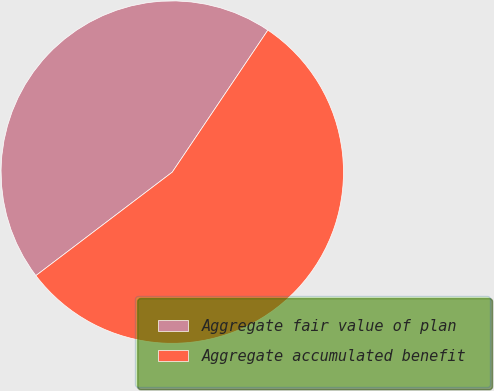Convert chart. <chart><loc_0><loc_0><loc_500><loc_500><pie_chart><fcel>Aggregate fair value of plan<fcel>Aggregate accumulated benefit<nl><fcel>44.76%<fcel>55.24%<nl></chart> 